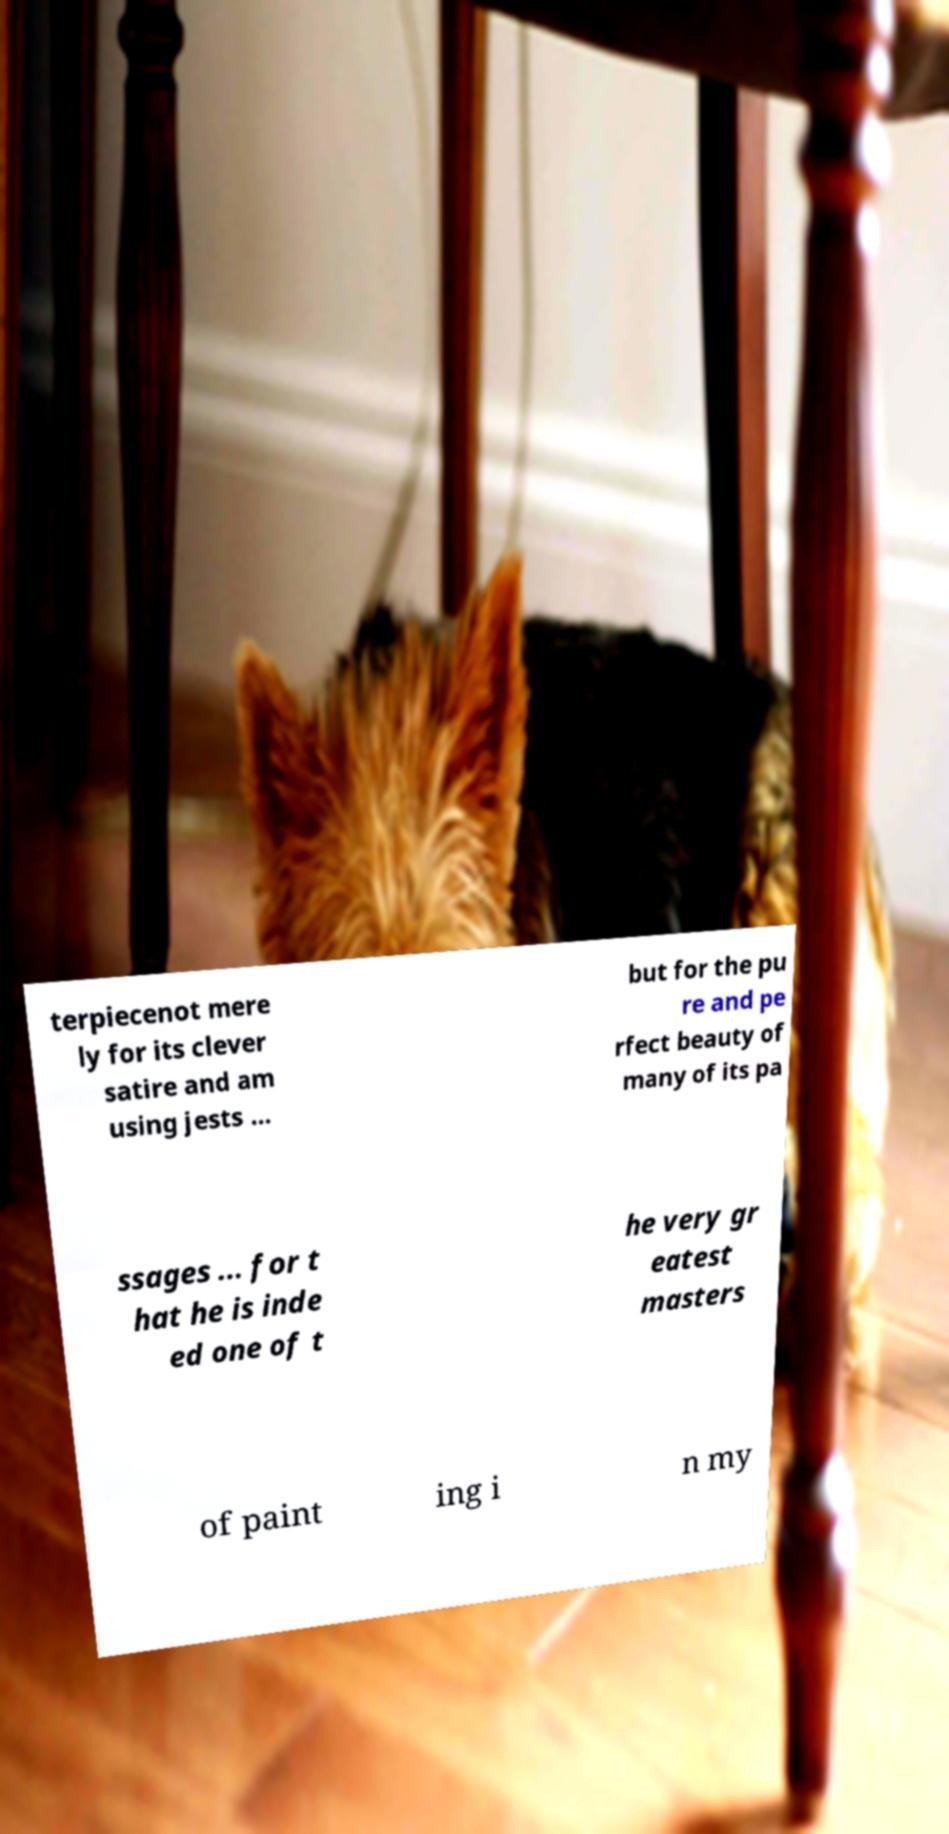I need the written content from this picture converted into text. Can you do that? terpiecenot mere ly for its clever satire and am using jests ... but for the pu re and pe rfect beauty of many of its pa ssages ... for t hat he is inde ed one of t he very gr eatest masters of paint ing i n my 